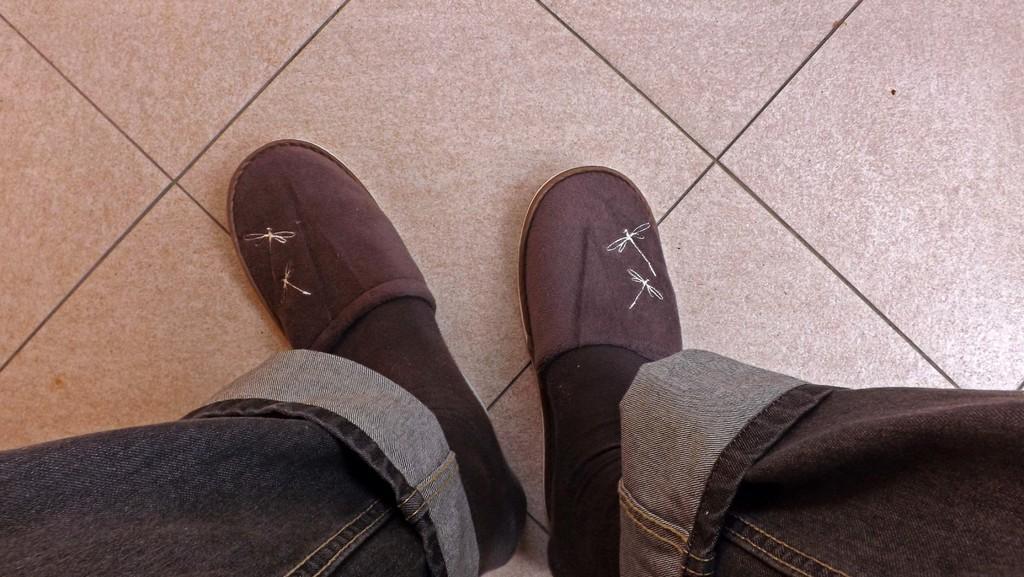How would you summarize this image in a sentence or two? We can see person's legs wore jeans,socks and footwear and we can see floor. 